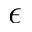Convert formula to latex. <formula><loc_0><loc_0><loc_500><loc_500>\epsilon</formula> 